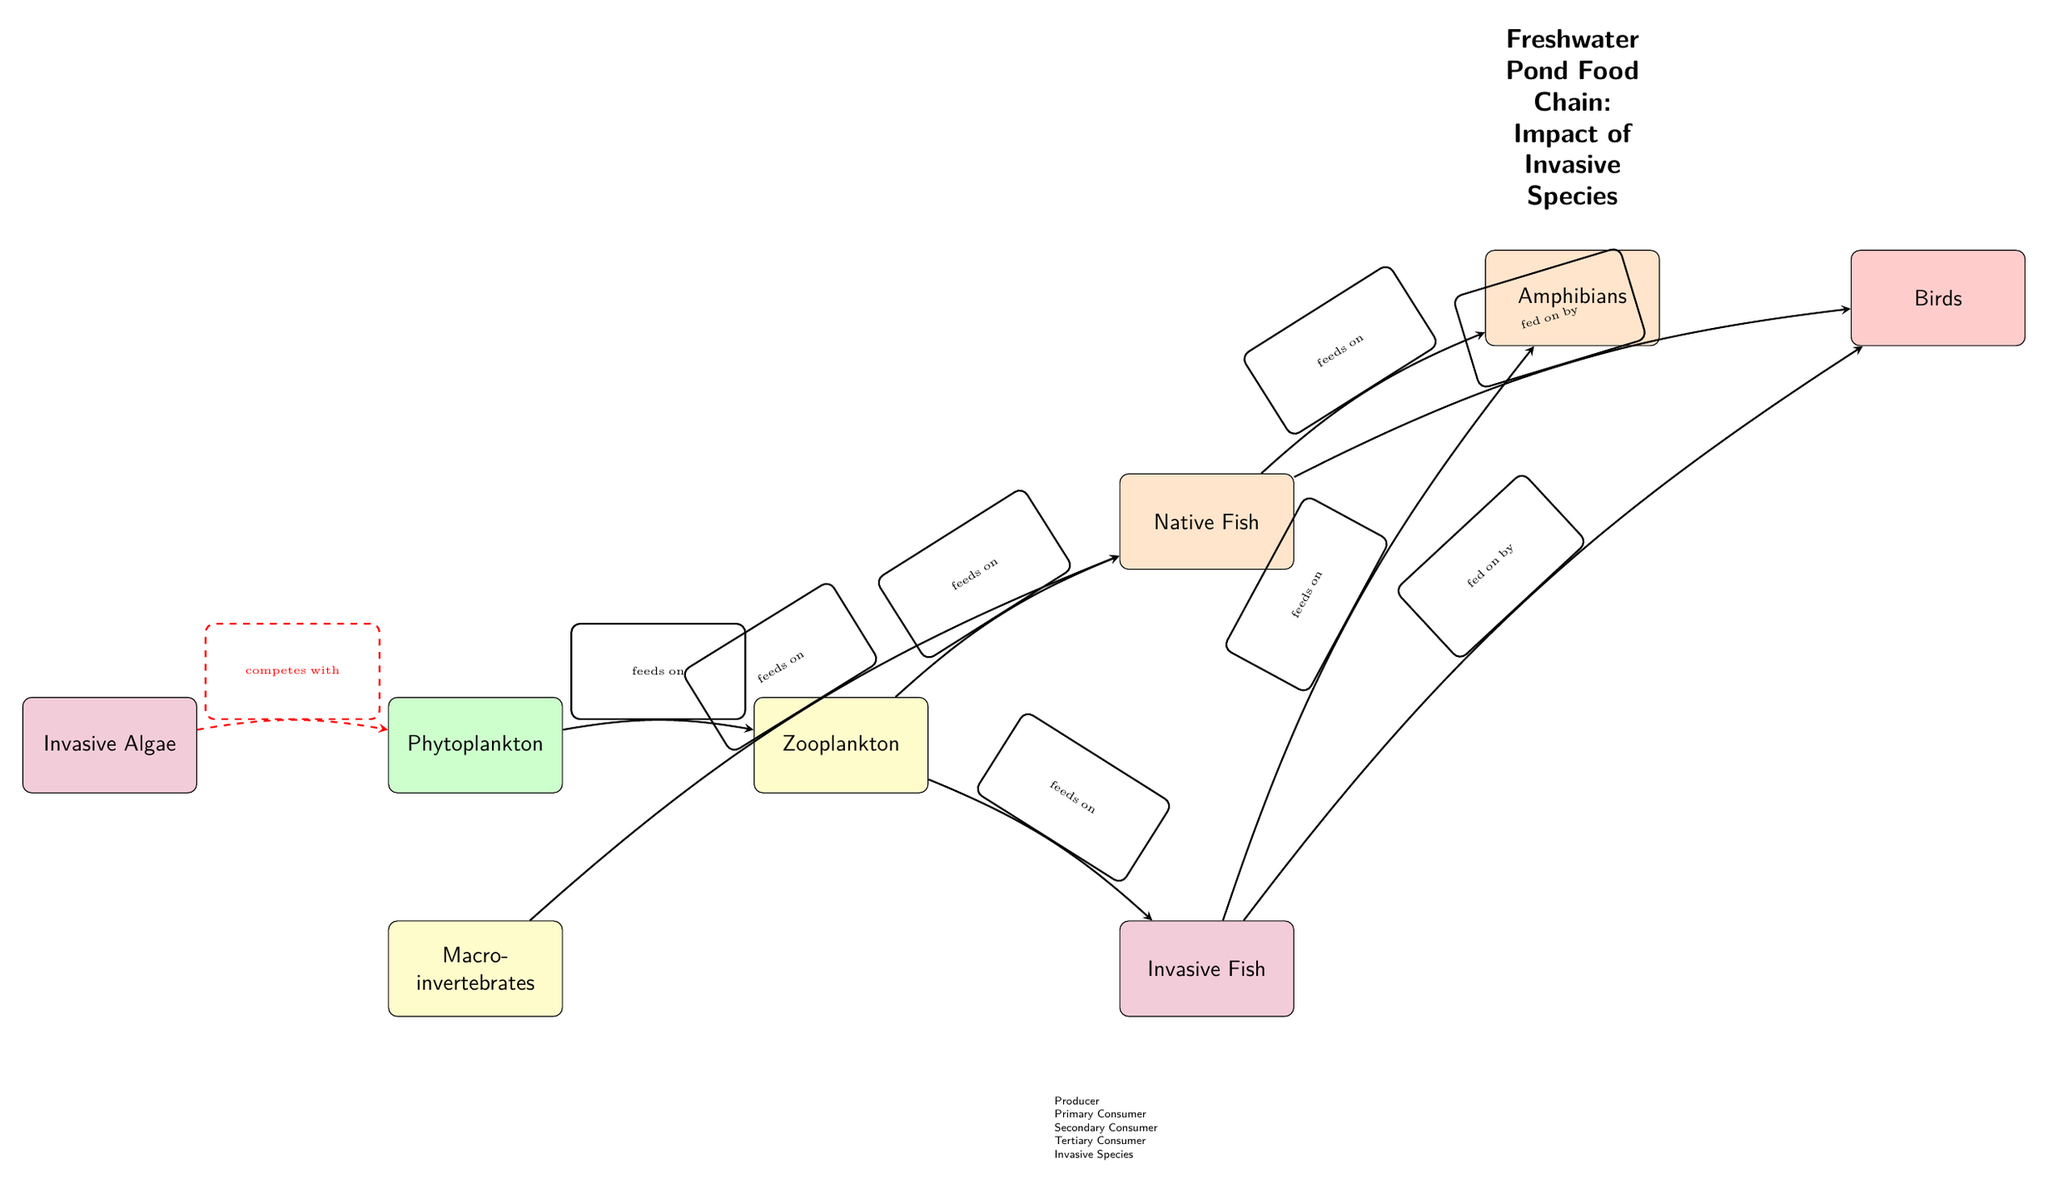What is the primary producer in this food chain? The diagram clearly labels "Phytoplankton" as the primary producer, indicated by the green color and its position at the beginning of the food chain.
Answer: Phytoplankton How many total consumers are there in the diagram? Counting the colored nodes designated as consumers (yellow, orange, and red), there are a total of four consumers: "Zooplankton," "Native Fish," "Invasive Fish," and "Amphibians."
Answer: 4 What does the invasive algae compete with? The diagram shows a dashed red arrow indicating competition from "Invasive Algae" to "Phytoplankton." This visual relationship directly illustrates the competitive interaction.
Answer: Phytoplankton Which invasive species feeds on amphibians? The diagram displays an arrow from "Invasive Fish" to "Amphibians," indicating that the invasive fish preys on amphibians. This relationship helps identify the impact of the invasive species on the native food web.
Answer: Invasive Fish How many species are depicted as tertiary consumers? The diagram shows "Birds" as the only tertiary consumer, which is the final consumer in the food chain, as indicated by its red color and its connection to both invasive and native fish.
Answer: 1 Which node is fed upon by the native fish? The diagram illustrates a flow from "Amphibians" to "Native Fish," confirming that native fish have amphibians as prey in this particular aquatic food chain.
Answer: Amphibians What is the role of zooplankton in this food chain? Zooplankton is categorized as a primary consumer, indicated by its yellow color. It occupies a middle position, feeding on phytoplankton and being preyed upon by both "Native Fish" and "Invasive Fish."
Answer: Primary Consumer What type of node are birds classified as? The diagram categorizes "Birds" as a tertiary consumer, associated with the highest level in the food chain, as denoted by its red color and its connection to previous consumers.
Answer: Tertiary Consumer 